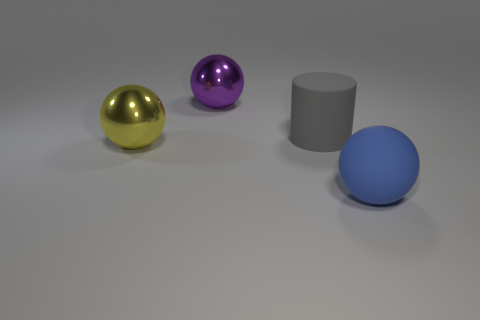Is the size of the metallic thing right of the yellow thing the same as the big cylinder?
Your response must be concise. Yes. What number of other big matte things have the same shape as the large gray rubber object?
Ensure brevity in your answer.  0. What shape is the gray matte thing?
Offer a very short reply. Cylinder. Are there the same number of gray cylinders in front of the large matte cylinder and large rubber things?
Make the answer very short. No. Do the ball right of the gray thing and the large purple thing have the same material?
Offer a terse response. No. Are there fewer purple things that are in front of the big purple shiny ball than large blue things?
Your answer should be compact. Yes. What number of rubber objects are tiny green cylinders or purple spheres?
Make the answer very short. 0. Does the cylinder have the same color as the big matte ball?
Offer a terse response. No. Is there anything else that is the same color as the rubber cylinder?
Ensure brevity in your answer.  No. Is the shape of the object left of the purple object the same as the metal object behind the big gray matte cylinder?
Provide a succinct answer. Yes. 